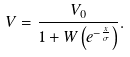Convert formula to latex. <formula><loc_0><loc_0><loc_500><loc_500>V = { \frac { V _ { 0 } } { 1 + W \left ( e ^ { - { \frac { x } { \sigma } } } \right ) } } .</formula> 